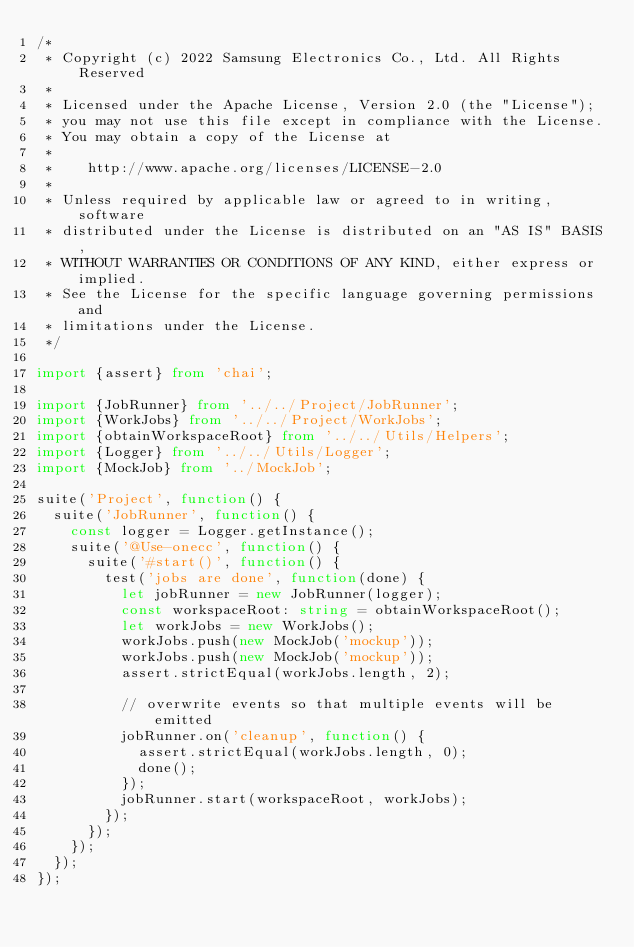Convert code to text. <code><loc_0><loc_0><loc_500><loc_500><_TypeScript_>/*
 * Copyright (c) 2022 Samsung Electronics Co., Ltd. All Rights Reserved
 *
 * Licensed under the Apache License, Version 2.0 (the "License");
 * you may not use this file except in compliance with the License.
 * You may obtain a copy of the License at
 *
 *    http://www.apache.org/licenses/LICENSE-2.0
 *
 * Unless required by applicable law or agreed to in writing, software
 * distributed under the License is distributed on an "AS IS" BASIS,
 * WITHOUT WARRANTIES OR CONDITIONS OF ANY KIND, either express or implied.
 * See the License for the specific language governing permissions and
 * limitations under the License.
 */

import {assert} from 'chai';

import {JobRunner} from '../../Project/JobRunner';
import {WorkJobs} from '../../Project/WorkJobs';
import {obtainWorkspaceRoot} from '../../Utils/Helpers';
import {Logger} from '../../Utils/Logger';
import {MockJob} from '../MockJob';

suite('Project', function() {
  suite('JobRunner', function() {
    const logger = Logger.getInstance();
    suite('@Use-onecc', function() {
      suite('#start()', function() {
        test('jobs are done', function(done) {
          let jobRunner = new JobRunner(logger);
          const workspaceRoot: string = obtainWorkspaceRoot();
          let workJobs = new WorkJobs();
          workJobs.push(new MockJob('mockup'));
          workJobs.push(new MockJob('mockup'));
          assert.strictEqual(workJobs.length, 2);

          // overwrite events so that multiple events will be emitted
          jobRunner.on('cleanup', function() {
            assert.strictEqual(workJobs.length, 0);
            done();
          });
          jobRunner.start(workspaceRoot, workJobs);
        });
      });
    });
  });
});
</code> 